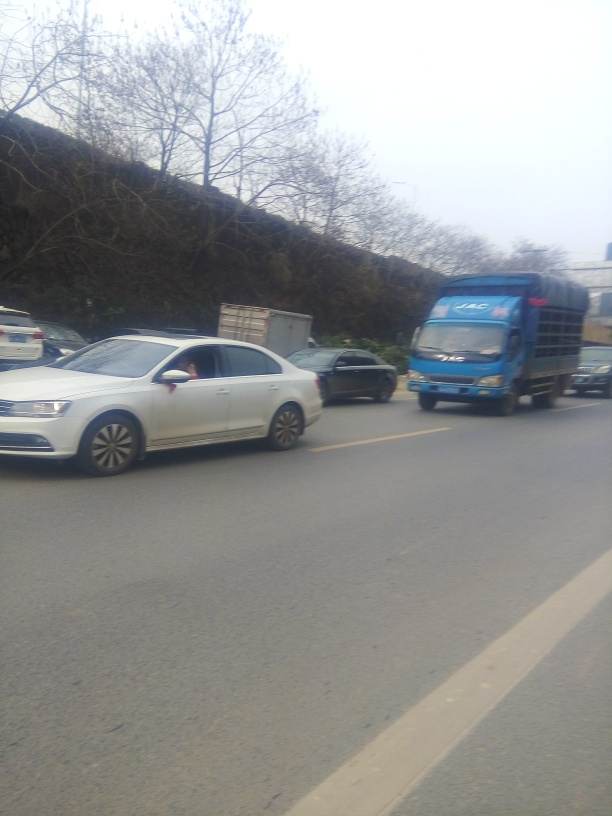Is there significant noise in the image?
 Yes 